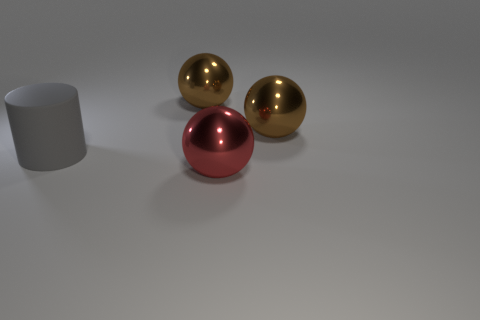Subtract all brown metallic spheres. How many spheres are left? 1 Add 4 cylinders. How many objects exist? 8 Subtract all brown spheres. How many spheres are left? 1 Subtract all cylinders. How many objects are left? 3 Subtract 2 spheres. How many spheres are left? 1 Subtract all red cylinders. Subtract all purple blocks. How many cylinders are left? 1 Subtract all green balls. How many red cylinders are left? 0 Subtract all cyan balls. Subtract all spheres. How many objects are left? 1 Add 3 large gray rubber cylinders. How many large gray rubber cylinders are left? 4 Add 2 big red rubber spheres. How many big red rubber spheres exist? 2 